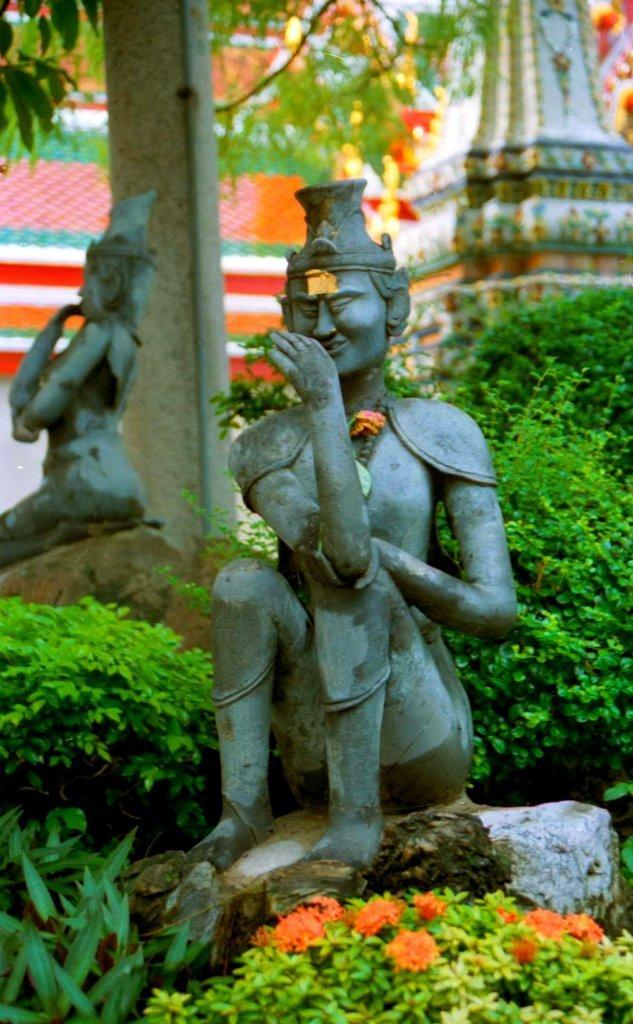Can you describe this image briefly? In the image there are two sculptures on the rocks and around those sculptures there are beautiful plants and in the background there is a pole, behind the pole there are branches of trees. 